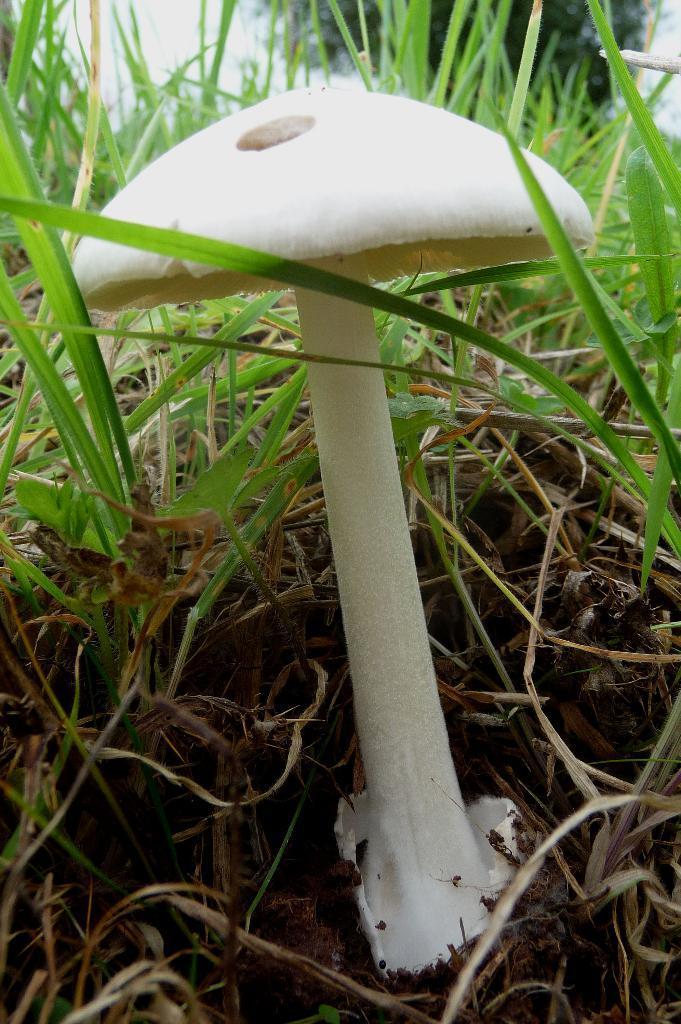Please provide a concise description of this image. In this image we can see a mushroom and grass on the ground. In the background we can see the sky and a tree. 